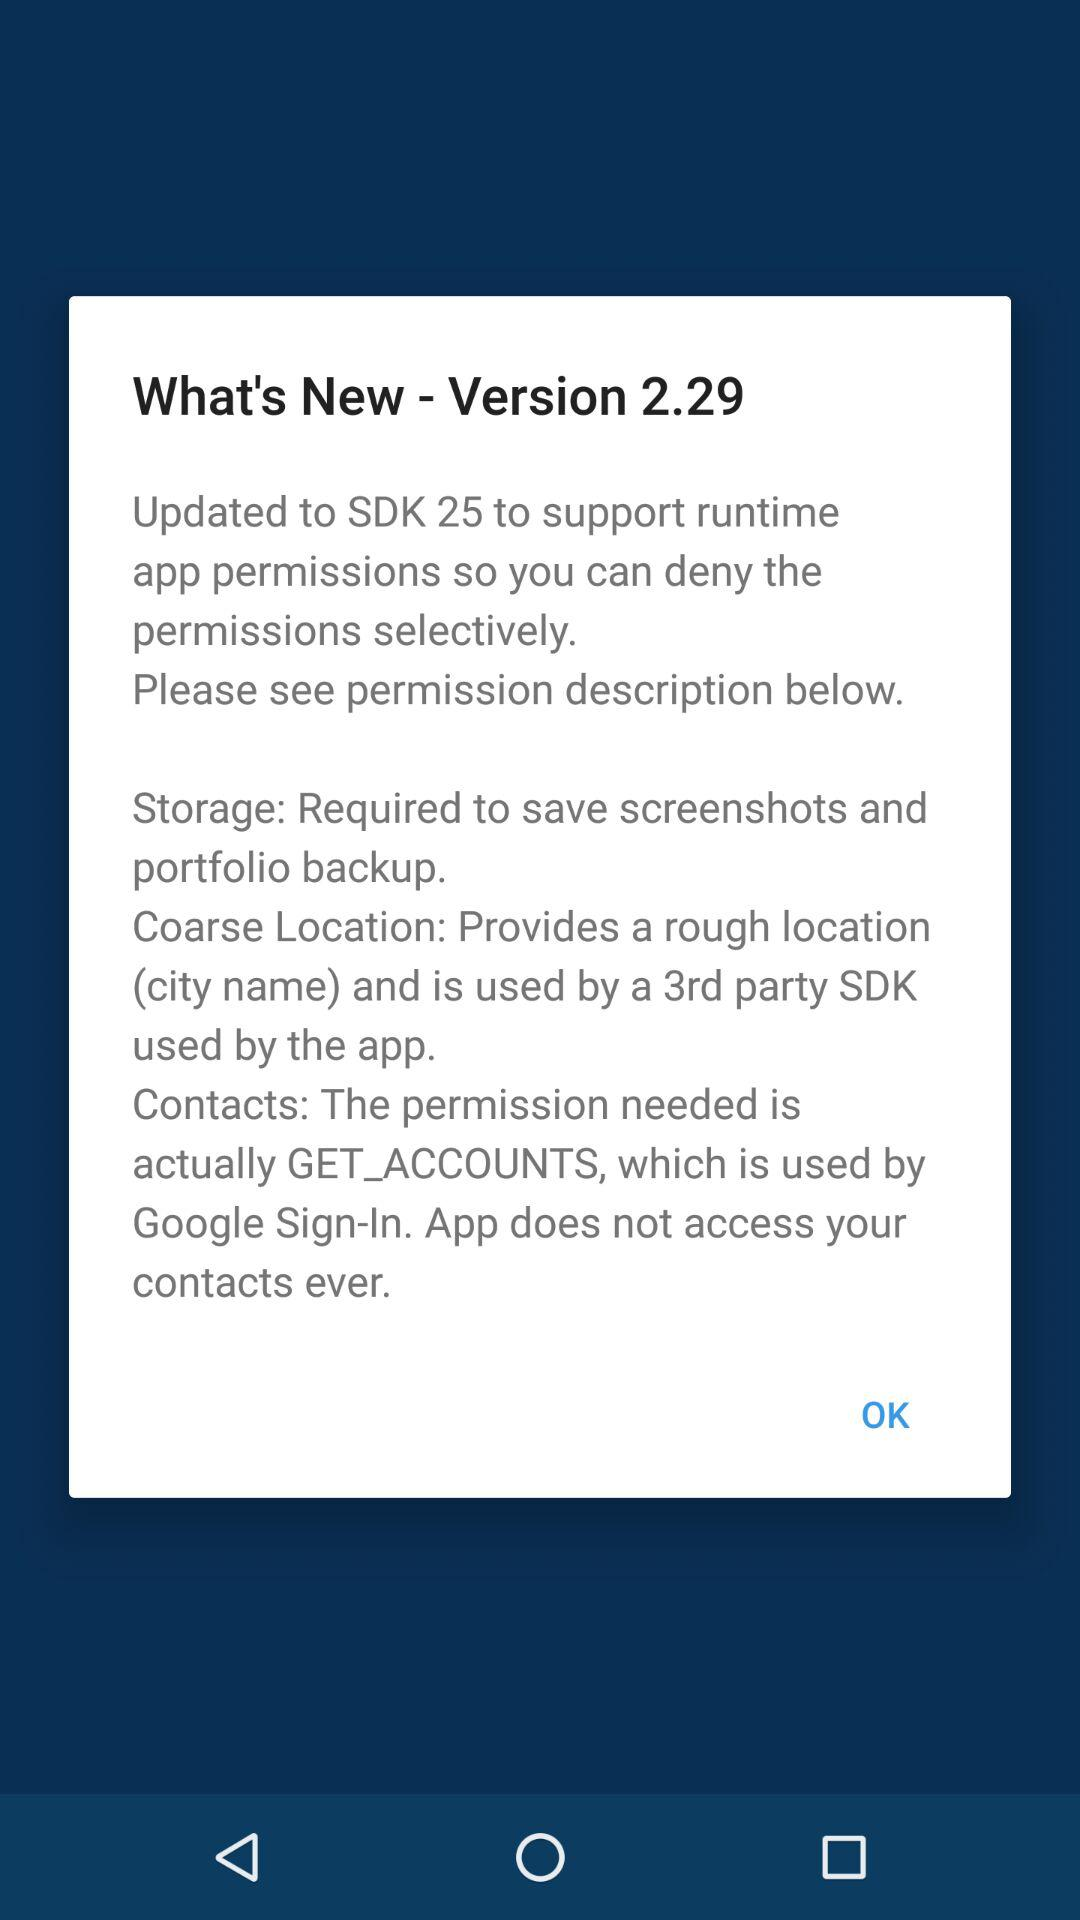How many permissions are required to save screenshots?
Answer the question using a single word or phrase. 1 